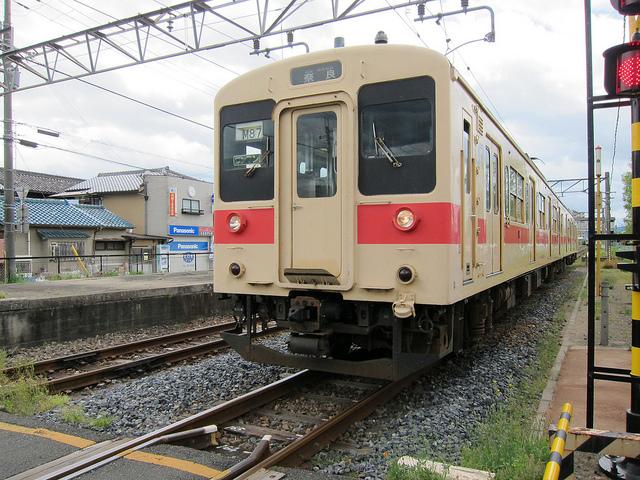What color is the stripe on the train?
Short answer required. Red. What colors is the train?
Short answer required. Tan and red. Is this train moving?
Give a very brief answer. Yes. Is this a passenger train?
Be succinct. Yes. What color is the train?
Be succinct. Brown. 